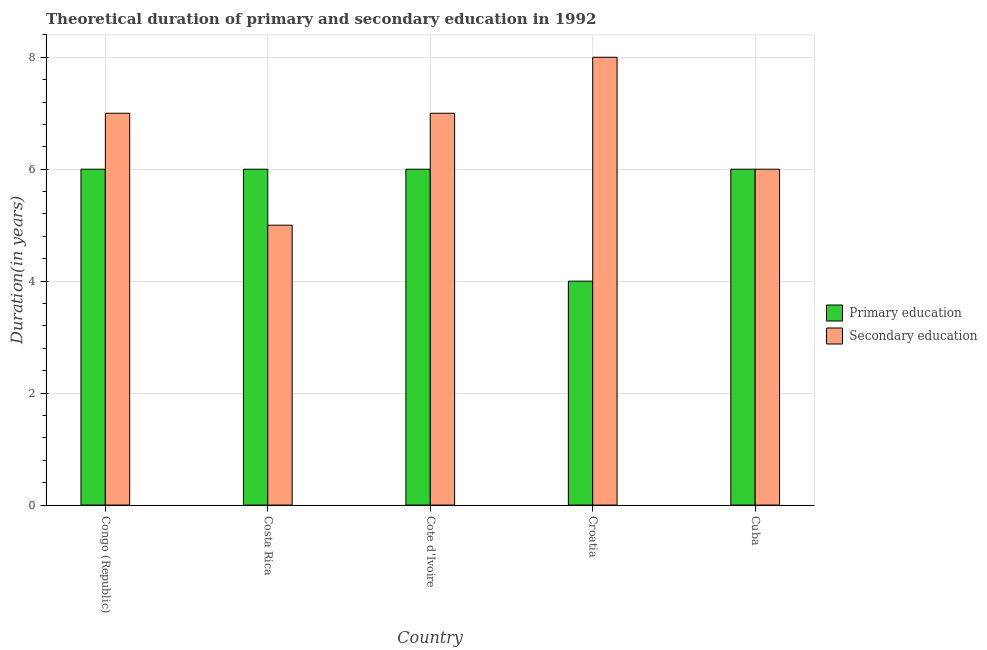How many groups of bars are there?
Provide a short and direct response. 5. Are the number of bars per tick equal to the number of legend labels?
Your answer should be compact. Yes. What is the label of the 5th group of bars from the left?
Provide a succinct answer. Cuba. In how many cases, is the number of bars for a given country not equal to the number of legend labels?
Offer a very short reply. 0. What is the duration of primary education in Croatia?
Give a very brief answer. 4. Across all countries, what is the minimum duration of secondary education?
Your answer should be compact. 5. In which country was the duration of secondary education maximum?
Provide a short and direct response. Croatia. What is the total duration of primary education in the graph?
Provide a short and direct response. 28. What is the difference between the duration of secondary education in Congo (Republic) and that in Croatia?
Your answer should be very brief. -1. What is the difference between the duration of primary education in Congo (Republic) and the duration of secondary education in Costa Rica?
Ensure brevity in your answer.  1. What is the average duration of secondary education per country?
Provide a succinct answer. 6.6. What is the difference between the duration of secondary education and duration of primary education in Croatia?
Provide a succinct answer. 4. In how many countries, is the duration of primary education greater than 1.6 years?
Provide a short and direct response. 5. What is the difference between the highest and the second highest duration of primary education?
Offer a terse response. 0. What is the difference between the highest and the lowest duration of secondary education?
Provide a succinct answer. 3. What does the 2nd bar from the left in Cuba represents?
Offer a terse response. Secondary education. What does the 1st bar from the right in Congo (Republic) represents?
Keep it short and to the point. Secondary education. How many bars are there?
Provide a short and direct response. 10. How many countries are there in the graph?
Make the answer very short. 5. What is the difference between two consecutive major ticks on the Y-axis?
Offer a terse response. 2. Are the values on the major ticks of Y-axis written in scientific E-notation?
Make the answer very short. No. How are the legend labels stacked?
Your answer should be compact. Vertical. What is the title of the graph?
Make the answer very short. Theoretical duration of primary and secondary education in 1992. Does "Primary income" appear as one of the legend labels in the graph?
Offer a terse response. No. What is the label or title of the X-axis?
Provide a short and direct response. Country. What is the label or title of the Y-axis?
Provide a succinct answer. Duration(in years). What is the Duration(in years) of Primary education in Costa Rica?
Your response must be concise. 6. What is the Duration(in years) of Primary education in Cote d'Ivoire?
Keep it short and to the point. 6. What is the Duration(in years) of Secondary education in Croatia?
Offer a terse response. 8. What is the Duration(in years) in Secondary education in Cuba?
Provide a short and direct response. 6. Across all countries, what is the maximum Duration(in years) of Secondary education?
Ensure brevity in your answer.  8. Across all countries, what is the minimum Duration(in years) in Primary education?
Ensure brevity in your answer.  4. Across all countries, what is the minimum Duration(in years) of Secondary education?
Your answer should be very brief. 5. What is the total Duration(in years) of Primary education in the graph?
Your answer should be compact. 28. What is the difference between the Duration(in years) in Secondary education in Congo (Republic) and that in Costa Rica?
Give a very brief answer. 2. What is the difference between the Duration(in years) in Primary education in Congo (Republic) and that in Cote d'Ivoire?
Make the answer very short. 0. What is the difference between the Duration(in years) in Secondary education in Congo (Republic) and that in Cote d'Ivoire?
Offer a very short reply. 0. What is the difference between the Duration(in years) in Primary education in Congo (Republic) and that in Croatia?
Offer a very short reply. 2. What is the difference between the Duration(in years) of Primary education in Congo (Republic) and that in Cuba?
Make the answer very short. 0. What is the difference between the Duration(in years) of Primary education in Costa Rica and that in Cote d'Ivoire?
Ensure brevity in your answer.  0. What is the difference between the Duration(in years) of Secondary education in Costa Rica and that in Cuba?
Give a very brief answer. -1. What is the difference between the Duration(in years) in Primary education in Cote d'Ivoire and that in Croatia?
Provide a succinct answer. 2. What is the difference between the Duration(in years) in Primary education in Cote d'Ivoire and that in Cuba?
Keep it short and to the point. 0. What is the difference between the Duration(in years) in Primary education in Croatia and that in Cuba?
Your answer should be very brief. -2. What is the difference between the Duration(in years) in Primary education in Congo (Republic) and the Duration(in years) in Secondary education in Costa Rica?
Your response must be concise. 1. What is the difference between the Duration(in years) of Primary education in Congo (Republic) and the Duration(in years) of Secondary education in Cote d'Ivoire?
Keep it short and to the point. -1. What is the difference between the Duration(in years) of Primary education in Costa Rica and the Duration(in years) of Secondary education in Croatia?
Offer a terse response. -2. What is the difference between the Duration(in years) of Primary education in Costa Rica and the Duration(in years) of Secondary education in Cuba?
Provide a succinct answer. 0. What is the difference between the Duration(in years) in Primary education in Cote d'Ivoire and the Duration(in years) in Secondary education in Croatia?
Provide a succinct answer. -2. What is the difference between the Duration(in years) in Primary education in Croatia and the Duration(in years) in Secondary education in Cuba?
Your answer should be very brief. -2. What is the difference between the Duration(in years) in Primary education and Duration(in years) in Secondary education in Cote d'Ivoire?
Give a very brief answer. -1. What is the ratio of the Duration(in years) in Primary education in Congo (Republic) to that in Costa Rica?
Your response must be concise. 1. What is the ratio of the Duration(in years) in Secondary education in Congo (Republic) to that in Costa Rica?
Your answer should be compact. 1.4. What is the ratio of the Duration(in years) in Secondary education in Congo (Republic) to that in Cote d'Ivoire?
Make the answer very short. 1. What is the ratio of the Duration(in years) of Secondary education in Congo (Republic) to that in Croatia?
Provide a short and direct response. 0.88. What is the ratio of the Duration(in years) of Primary education in Congo (Republic) to that in Cuba?
Ensure brevity in your answer.  1. What is the ratio of the Duration(in years) of Secondary education in Costa Rica to that in Cote d'Ivoire?
Ensure brevity in your answer.  0.71. What is the ratio of the Duration(in years) in Primary education in Costa Rica to that in Croatia?
Your response must be concise. 1.5. What is the ratio of the Duration(in years) of Primary education in Costa Rica to that in Cuba?
Offer a very short reply. 1. What is the ratio of the Duration(in years) of Secondary education in Costa Rica to that in Cuba?
Make the answer very short. 0.83. What is the ratio of the Duration(in years) in Primary education in Cote d'Ivoire to that in Croatia?
Your answer should be compact. 1.5. What is the ratio of the Duration(in years) of Primary education in Croatia to that in Cuba?
Your answer should be compact. 0.67. What is the ratio of the Duration(in years) of Secondary education in Croatia to that in Cuba?
Your response must be concise. 1.33. What is the difference between the highest and the second highest Duration(in years) in Secondary education?
Keep it short and to the point. 1. What is the difference between the highest and the lowest Duration(in years) of Secondary education?
Give a very brief answer. 3. 